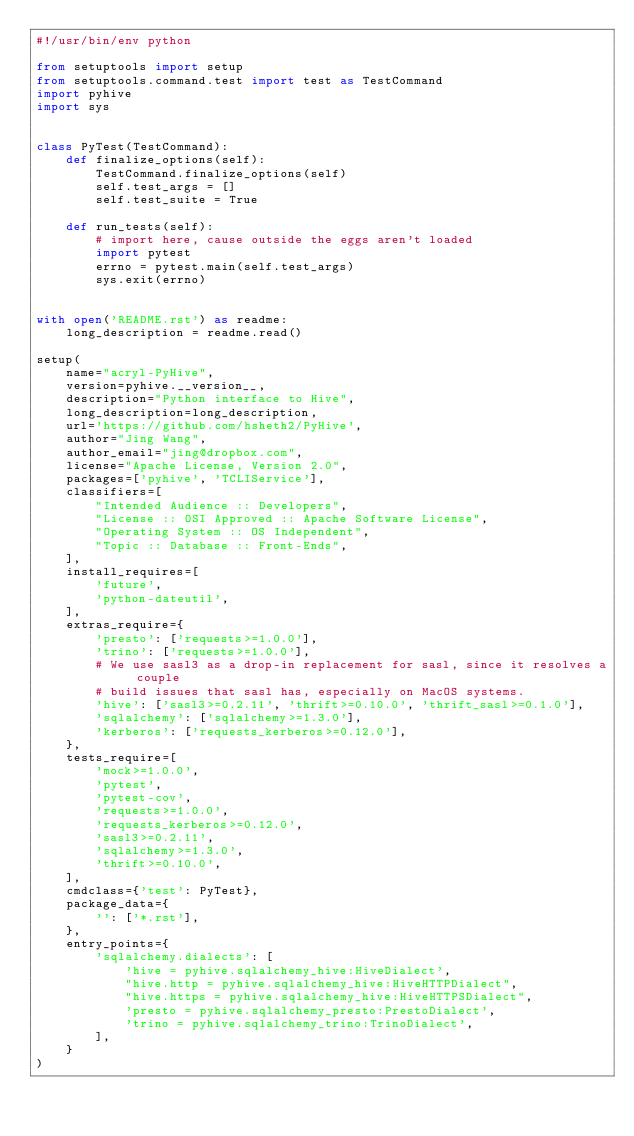Convert code to text. <code><loc_0><loc_0><loc_500><loc_500><_Python_>#!/usr/bin/env python

from setuptools import setup
from setuptools.command.test import test as TestCommand
import pyhive
import sys


class PyTest(TestCommand):
    def finalize_options(self):
        TestCommand.finalize_options(self)
        self.test_args = []
        self.test_suite = True

    def run_tests(self):
        # import here, cause outside the eggs aren't loaded
        import pytest
        errno = pytest.main(self.test_args)
        sys.exit(errno)


with open('README.rst') as readme:
    long_description = readme.read()

setup(
    name="acryl-PyHive",
    version=pyhive.__version__,
    description="Python interface to Hive",
    long_description=long_description,
    url='https://github.com/hsheth2/PyHive',
    author="Jing Wang",
    author_email="jing@dropbox.com",
    license="Apache License, Version 2.0",
    packages=['pyhive', 'TCLIService'],
    classifiers=[
        "Intended Audience :: Developers",
        "License :: OSI Approved :: Apache Software License",
        "Operating System :: OS Independent",
        "Topic :: Database :: Front-Ends",
    ],
    install_requires=[
        'future',
        'python-dateutil',
    ],
    extras_require={
        'presto': ['requests>=1.0.0'],
        'trino': ['requests>=1.0.0'],
        # We use sasl3 as a drop-in replacement for sasl, since it resolves a couple
        # build issues that sasl has, especially on MacOS systems.
        'hive': ['sasl3>=0.2.11', 'thrift>=0.10.0', 'thrift_sasl>=0.1.0'],
        'sqlalchemy': ['sqlalchemy>=1.3.0'],
        'kerberos': ['requests_kerberos>=0.12.0'],
    },
    tests_require=[
        'mock>=1.0.0',
        'pytest',
        'pytest-cov',
        'requests>=1.0.0',
        'requests_kerberos>=0.12.0',
        'sasl3>=0.2.11',
        'sqlalchemy>=1.3.0',
        'thrift>=0.10.0',
    ],
    cmdclass={'test': PyTest},
    package_data={
        '': ['*.rst'],
    },
    entry_points={
        'sqlalchemy.dialects': [
            'hive = pyhive.sqlalchemy_hive:HiveDialect',
            "hive.http = pyhive.sqlalchemy_hive:HiveHTTPDialect",
            "hive.https = pyhive.sqlalchemy_hive:HiveHTTPSDialect",
            'presto = pyhive.sqlalchemy_presto:PrestoDialect',
            'trino = pyhive.sqlalchemy_trino:TrinoDialect',
        ],
    }
)
</code> 